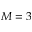Convert formula to latex. <formula><loc_0><loc_0><loc_500><loc_500>M = 3</formula> 